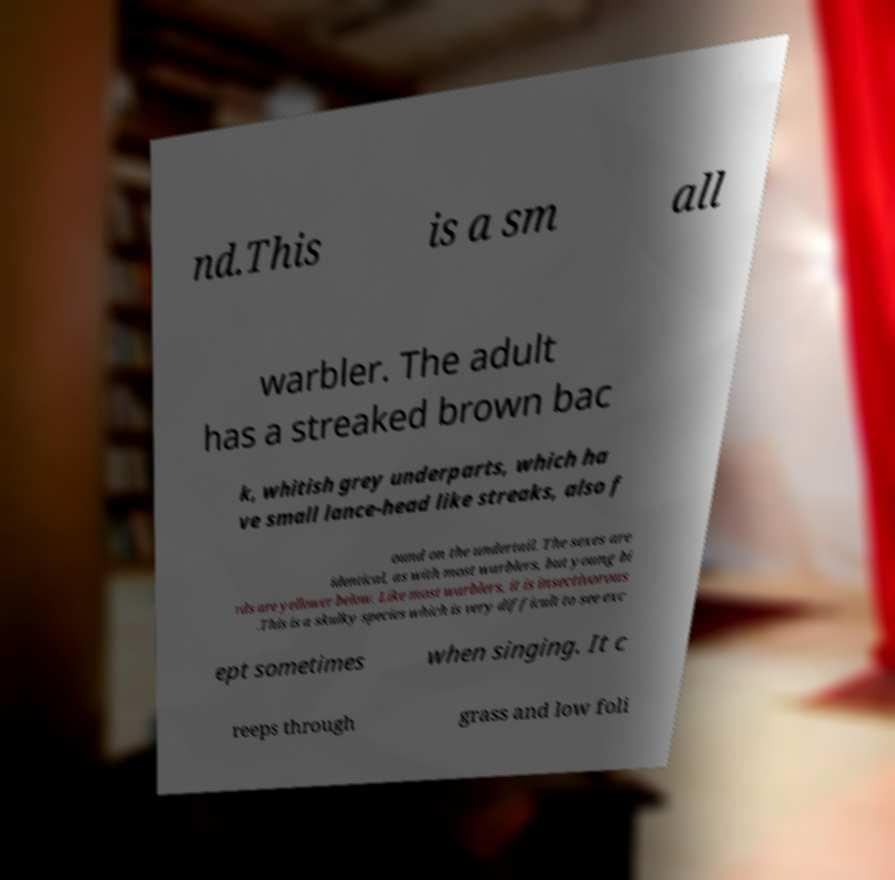What messages or text are displayed in this image? I need them in a readable, typed format. nd.This is a sm all warbler. The adult has a streaked brown bac k, whitish grey underparts, which ha ve small lance-head like streaks, also f ound on the undertail. The sexes are identical, as with most warblers, but young bi rds are yellower below. Like most warblers, it is insectivorous .This is a skulky species which is very difficult to see exc ept sometimes when singing. It c reeps through grass and low foli 